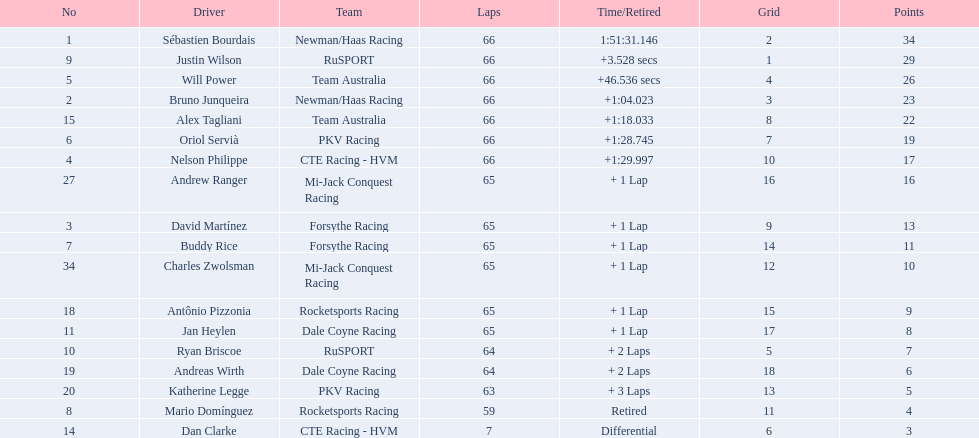Parse the full table in json format. {'header': ['No', 'Driver', 'Team', 'Laps', 'Time/Retired', 'Grid', 'Points'], 'rows': [['1', 'Sébastien Bourdais', 'Newman/Haas Racing', '66', '1:51:31.146', '2', '34'], ['9', 'Justin Wilson', 'RuSPORT', '66', '+3.528 secs', '1', '29'], ['5', 'Will Power', 'Team Australia', '66', '+46.536 secs', '4', '26'], ['2', 'Bruno Junqueira', 'Newman/Haas Racing', '66', '+1:04.023', '3', '23'], ['15', 'Alex Tagliani', 'Team Australia', '66', '+1:18.033', '8', '22'], ['6', 'Oriol Servià', 'PKV Racing', '66', '+1:28.745', '7', '19'], ['4', 'Nelson Philippe', 'CTE Racing - HVM', '66', '+1:29.997', '10', '17'], ['27', 'Andrew Ranger', 'Mi-Jack Conquest Racing', '65', '+ 1 Lap', '16', '16'], ['3', 'David Martínez', 'Forsythe Racing', '65', '+ 1 Lap', '9', '13'], ['7', 'Buddy Rice', 'Forsythe Racing', '65', '+ 1 Lap', '14', '11'], ['34', 'Charles Zwolsman', 'Mi-Jack Conquest Racing', '65', '+ 1 Lap', '12', '10'], ['18', 'Antônio Pizzonia', 'Rocketsports Racing', '65', '+ 1 Lap', '15', '9'], ['11', 'Jan Heylen', 'Dale Coyne Racing', '65', '+ 1 Lap', '17', '8'], ['10', 'Ryan Briscoe', 'RuSPORT', '64', '+ 2 Laps', '5', '7'], ['19', 'Andreas Wirth', 'Dale Coyne Racing', '64', '+ 2 Laps', '18', '6'], ['20', 'Katherine Legge', 'PKV Racing', '63', '+ 3 Laps', '13', '5'], ['8', 'Mario Domínguez', 'Rocketsports Racing', '59', 'Retired', '11', '4'], ['14', 'Dan Clarke', 'CTE Racing - HVM', '7', 'Differential', '6', '3']]} How many laps did oriol servia complete at the 2006 gran premio? 66. How many laps did katherine legge complete at the 2006 gran premio? 63. Between servia and legge, who completed more laps? Oriol Servià. 